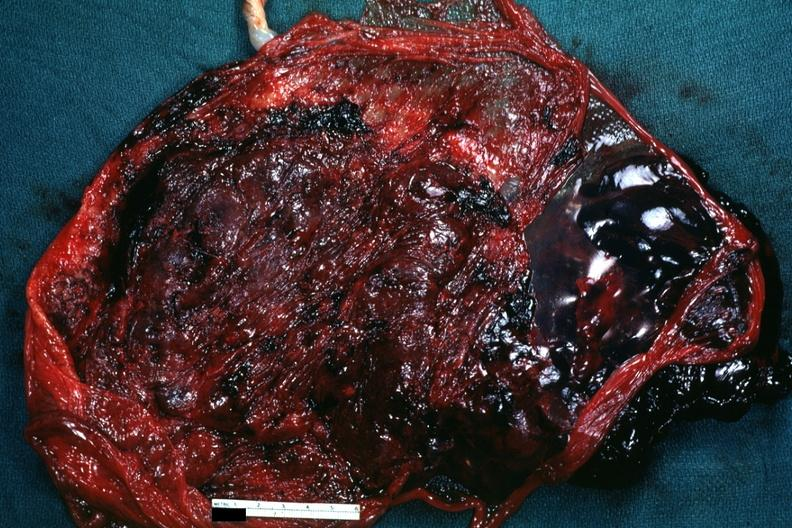s abruption present?
Answer the question using a single word or phrase. Yes 